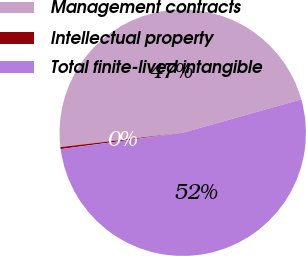Convert chart to OTSL. <chart><loc_0><loc_0><loc_500><loc_500><pie_chart><fcel>Management contracts<fcel>Intellectual property<fcel>Total finite-lived intangible<nl><fcel>47.5%<fcel>0.26%<fcel>52.25%<nl></chart> 